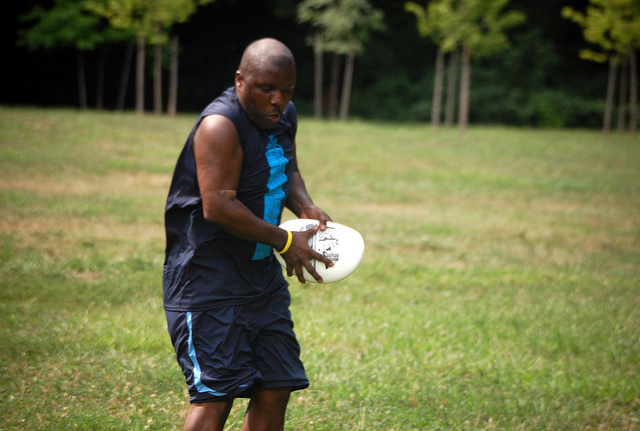<image>What color is the soccer ball? There is no soccer ball in the image. However, it can be white. What color is the soccer ball? There is no soccer ball in the image. 